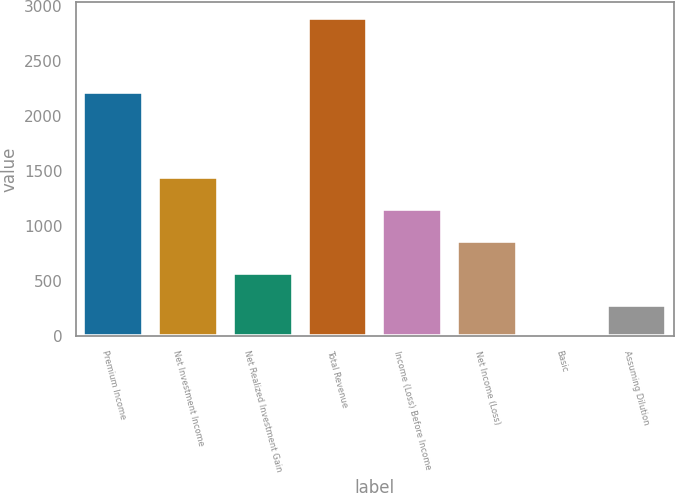<chart> <loc_0><loc_0><loc_500><loc_500><bar_chart><fcel>Premium Income<fcel>Net Investment Income<fcel>Net Realized Investment Gain<fcel>Total Revenue<fcel>Income (Loss) Before Income<fcel>Net Income (Loss)<fcel>Basic<fcel>Assuming Dilution<nl><fcel>2221<fcel>1445.79<fcel>579.09<fcel>2890.3<fcel>1156.89<fcel>867.99<fcel>1.29<fcel>290.19<nl></chart> 